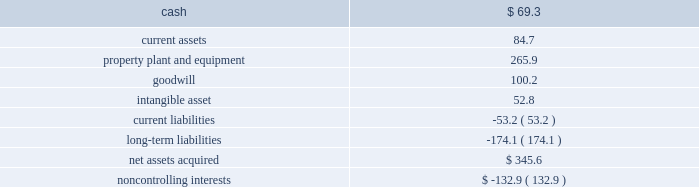Page 45 of 100 ball corporation and subsidiaries notes to consolidated financial statements 3 .
Acquisitions latapack-ball embalagens ltda .
( latapack-ball ) in august 2010 , the company paid $ 46.2 million to acquire an additional 10.1 percent economic interest in its brazilian beverage packaging joint venture , latapack-ball , through a transaction with the joint venture partner , latapack s.a .
This transaction increased the company 2019s overall economic interest in the joint venture to 60.1 percent and expands and strengthens ball 2019s presence in the growing brazilian market .
As a result of the transaction , latapack-ball became a variable interest entity ( vie ) under consolidation accounting guidelines with ball being identified as the primary beneficiary of the vie and consolidating the joint venture .
Latapack-ball operates metal beverage packaging manufacturing plants in tres rios , jacarei and salvador , brazil and has been included in the metal beverage packaging , americas and asia , reporting segment .
In connection with the acquisition , the company recorded a gain of $ 81.8 million on its previously held equity investment in latapack-ball as a result of required purchase accounting .
The table summarizes the final fair values of the latapack-ball assets acquired , liabilities assumed and non- controlling interest recognized , as well as the related investment in latapack s.a. , as of the acquisition date .
The valuation was based on market and income approaches. .
Noncontrolling interests $ ( 132.9 ) the customer relationships were identified as an intangible asset by the company and assigned an estimated life of 13.4 years .
The intangible asset is being amortized on a straight-line basis .
Neuman aluminum ( neuman ) in july 2010 , the company acquired neuman for approximately $ 62 million in cash .
Neuman had sales of approximately $ 128 million in 2009 ( unaudited ) and is the leading north american manufacturer of aluminum slugs used to make extruded aerosol cans , beverage bottles , aluminum collapsible tubes and technical impact extrusions .
Neuman operates two plants , one in the united states and one in canada , which employ approximately 180 people .
The acquisition of neuman is not material to the metal food and household products packaging , americas , segment , in which its results of operations have been included since the acquisition date .
Guangdong jianlibao group co. , ltd ( jianlibao ) in june 2010 , the company acquired jianlibao 2019s 65 percent interest in a joint venture metal beverage can and end plant in sanshui ( foshan ) , prc .
Ball has owned 35 percent of the joint venture plant since 1992 .
Ball acquired the 65 percent interest for $ 86.9 million in cash ( net of cash acquired ) and assumed debt , and also entered into a long-term supply agreement with jianlibao and one of its affiliates .
The company recorded equity earnings of $ 24.1 million , which was composed of equity earnings and a gain realized on the fair value of ball 2019s previous 35 percent equity investment as a result of required purchase accounting .
The purchase accounting was completed during the third quarter of 2010 .
The acquisition of the remaining interest is not material to the metal beverage packaging , americas and asia , segment. .
What was the implied total value in millions of the brazilian beverage packaging joint venture , latapack-ball , in august 2010? 
Computations: (46.2 / (10.1 / 100))
Answer: 457.42574. 